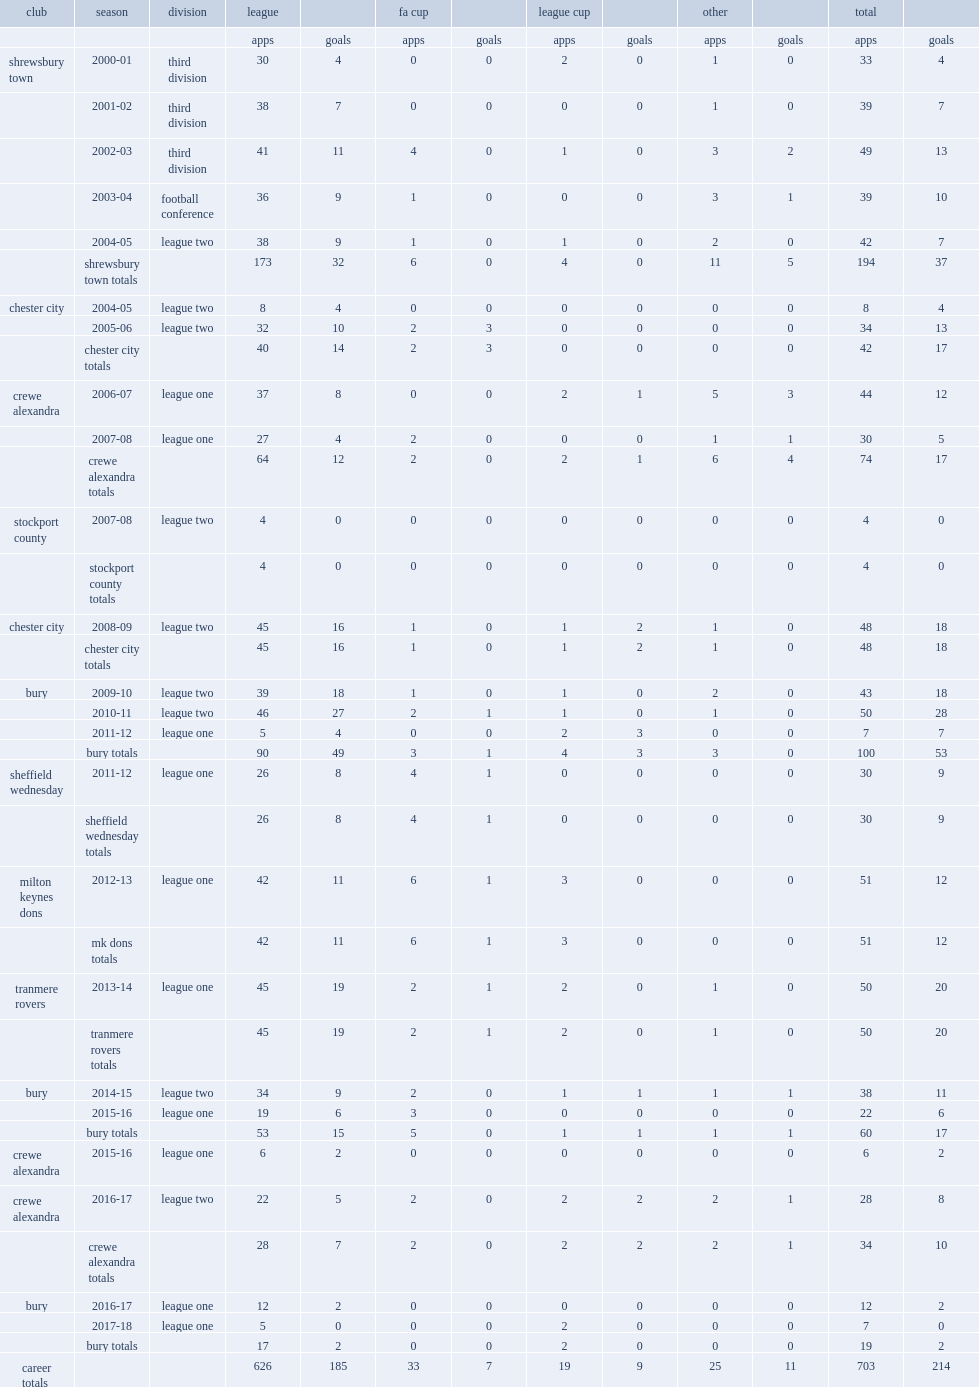In 2006-07 season, which league did ryan lowe play for crewe alexandra? League one. 